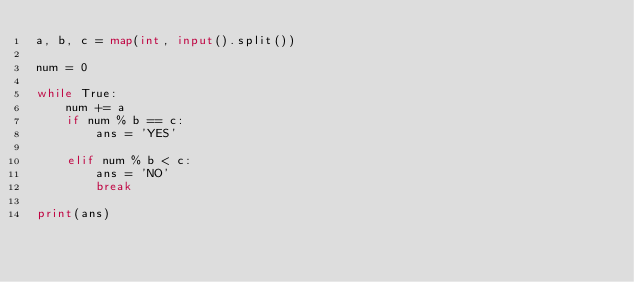Convert code to text. <code><loc_0><loc_0><loc_500><loc_500><_Python_>a, b, c = map(int, input().split())

num = 0

while True:
    num += a
    if num % b == c:
        ans = 'YES'

    elif num % b < c:
        ans = 'NO'
        break

print(ans)
</code> 